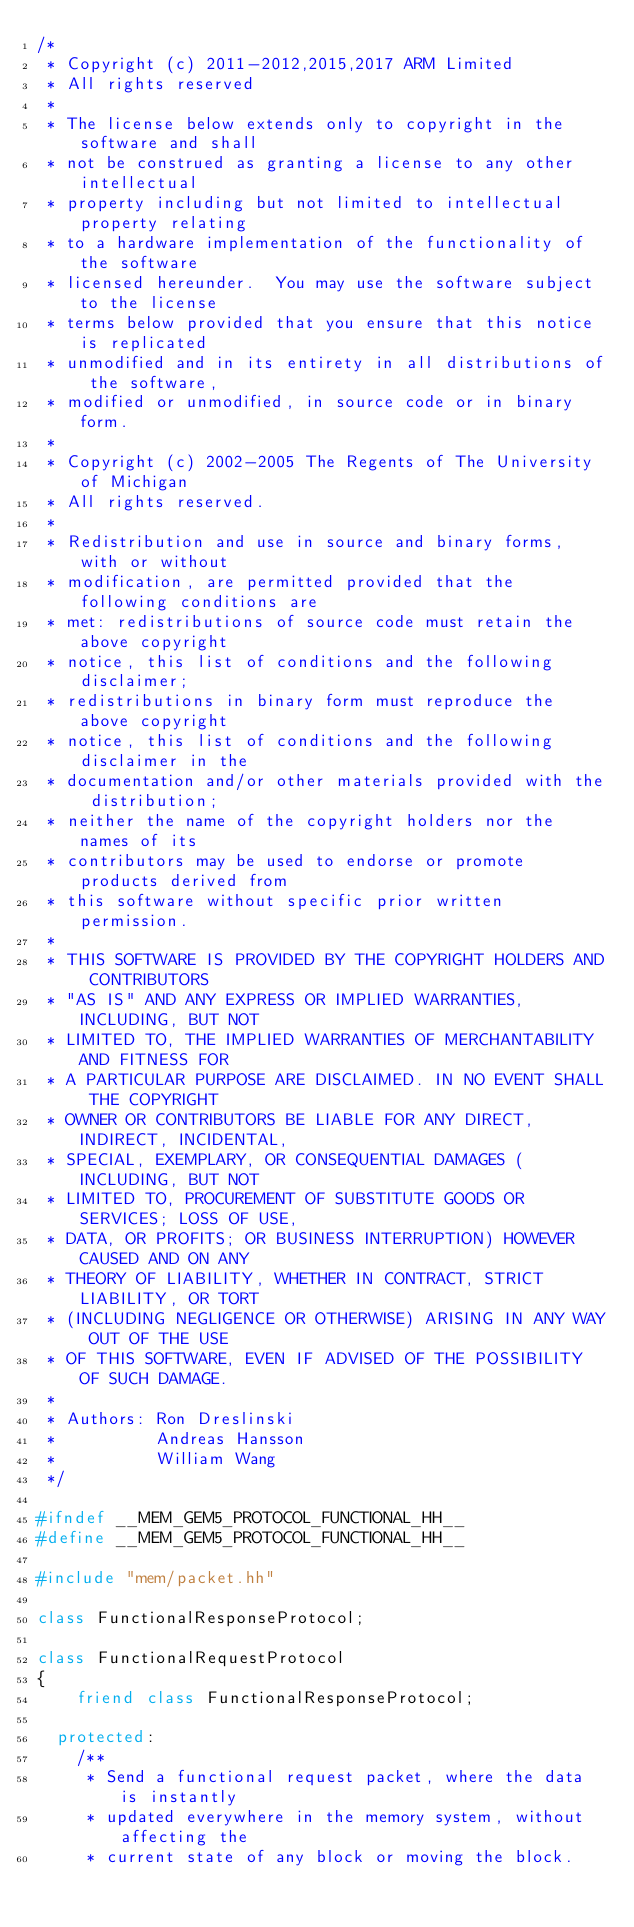Convert code to text. <code><loc_0><loc_0><loc_500><loc_500><_C++_>/*
 * Copyright (c) 2011-2012,2015,2017 ARM Limited
 * All rights reserved
 *
 * The license below extends only to copyright in the software and shall
 * not be construed as granting a license to any other intellectual
 * property including but not limited to intellectual property relating
 * to a hardware implementation of the functionality of the software
 * licensed hereunder.  You may use the software subject to the license
 * terms below provided that you ensure that this notice is replicated
 * unmodified and in its entirety in all distributions of the software,
 * modified or unmodified, in source code or in binary form.
 *
 * Copyright (c) 2002-2005 The Regents of The University of Michigan
 * All rights reserved.
 *
 * Redistribution and use in source and binary forms, with or without
 * modification, are permitted provided that the following conditions are
 * met: redistributions of source code must retain the above copyright
 * notice, this list of conditions and the following disclaimer;
 * redistributions in binary form must reproduce the above copyright
 * notice, this list of conditions and the following disclaimer in the
 * documentation and/or other materials provided with the distribution;
 * neither the name of the copyright holders nor the names of its
 * contributors may be used to endorse or promote products derived from
 * this software without specific prior written permission.
 *
 * THIS SOFTWARE IS PROVIDED BY THE COPYRIGHT HOLDERS AND CONTRIBUTORS
 * "AS IS" AND ANY EXPRESS OR IMPLIED WARRANTIES, INCLUDING, BUT NOT
 * LIMITED TO, THE IMPLIED WARRANTIES OF MERCHANTABILITY AND FITNESS FOR
 * A PARTICULAR PURPOSE ARE DISCLAIMED. IN NO EVENT SHALL THE COPYRIGHT
 * OWNER OR CONTRIBUTORS BE LIABLE FOR ANY DIRECT, INDIRECT, INCIDENTAL,
 * SPECIAL, EXEMPLARY, OR CONSEQUENTIAL DAMAGES (INCLUDING, BUT NOT
 * LIMITED TO, PROCUREMENT OF SUBSTITUTE GOODS OR SERVICES; LOSS OF USE,
 * DATA, OR PROFITS; OR BUSINESS INTERRUPTION) HOWEVER CAUSED AND ON ANY
 * THEORY OF LIABILITY, WHETHER IN CONTRACT, STRICT LIABILITY, OR TORT
 * (INCLUDING NEGLIGENCE OR OTHERWISE) ARISING IN ANY WAY OUT OF THE USE
 * OF THIS SOFTWARE, EVEN IF ADVISED OF THE POSSIBILITY OF SUCH DAMAGE.
 *
 * Authors: Ron Dreslinski
 *          Andreas Hansson
 *          William Wang
 */

#ifndef __MEM_GEM5_PROTOCOL_FUNCTIONAL_HH__
#define __MEM_GEM5_PROTOCOL_FUNCTIONAL_HH__

#include "mem/packet.hh"

class FunctionalResponseProtocol;

class FunctionalRequestProtocol
{
    friend class FunctionalResponseProtocol;

  protected:
    /**
     * Send a functional request packet, where the data is instantly
     * updated everywhere in the memory system, without affecting the
     * current state of any block or moving the block.</code> 